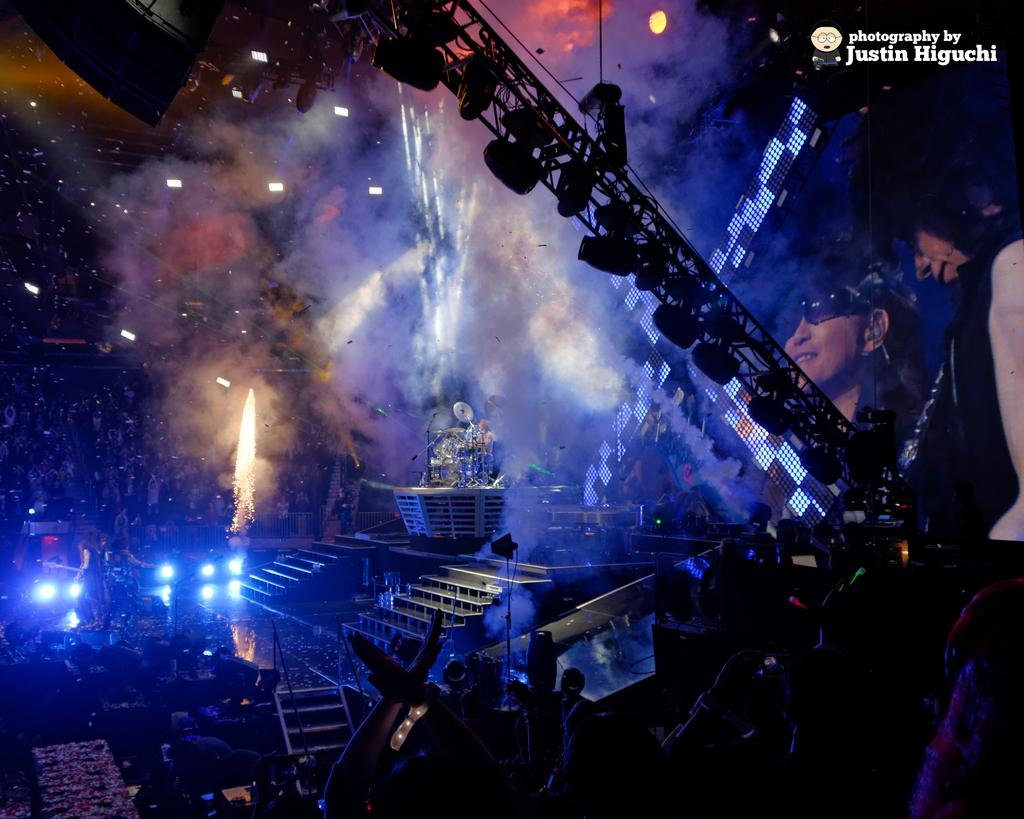What type of lights can be seen in the image? There are focus lights in the image. What structure is present in the image that supports lighting equipment? There is a lighting truss in the image. What can be seen on the stage in the image? There is a screen and a person playing the drums on the stage. How many people are visible in the image? There is a group of people in the image. Is there any indication of ownership or origin on the image? Yes, there is a watermark on the image. How does the society contribute to the peace in the image? The image does not depict any society or peace; it features focus lights, a lighting truss, a screen, a group of people, a person playing the drums, and a watermark. What type of hole can be seen in the image? There is no hole present in the image. 